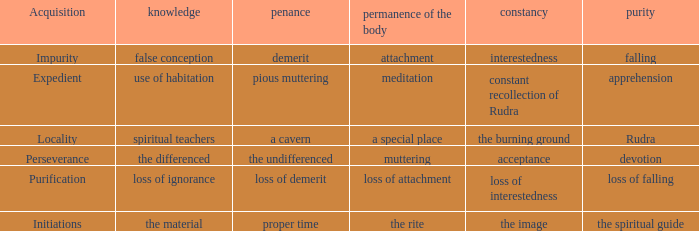What is the lastingness of the body where expiation is the uniform? Muttering. 